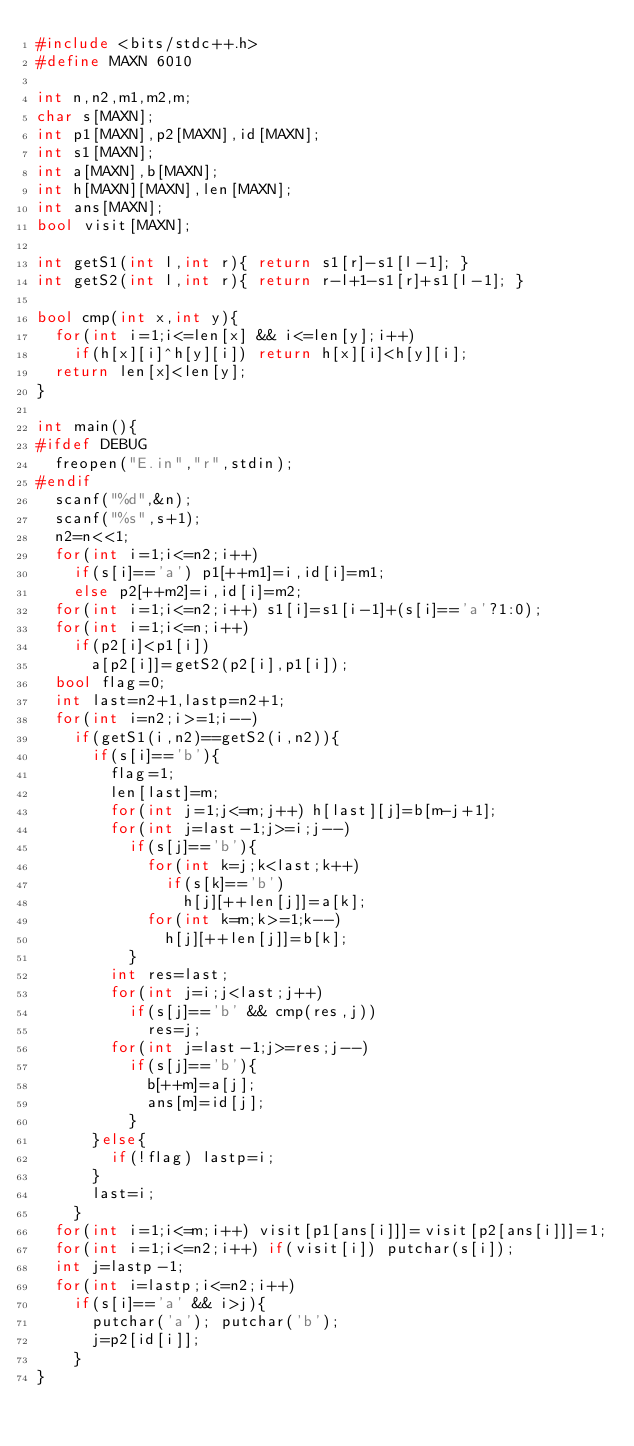<code> <loc_0><loc_0><loc_500><loc_500><_C++_>#include <bits/stdc++.h>
#define MAXN 6010

int n,n2,m1,m2,m;
char s[MAXN];
int p1[MAXN],p2[MAXN],id[MAXN];
int s1[MAXN];
int a[MAXN],b[MAXN];
int h[MAXN][MAXN],len[MAXN];
int ans[MAXN];
bool visit[MAXN];

int getS1(int l,int r){ return s1[r]-s1[l-1]; }
int getS2(int l,int r){ return r-l+1-s1[r]+s1[l-1]; }

bool cmp(int x,int y){
	for(int i=1;i<=len[x] && i<=len[y];i++)
		if(h[x][i]^h[y][i]) return h[x][i]<h[y][i];
	return len[x]<len[y];
}

int main(){
#ifdef DEBUG
	freopen("E.in","r",stdin);
#endif
	scanf("%d",&n);
	scanf("%s",s+1);
	n2=n<<1;
	for(int i=1;i<=n2;i++)
		if(s[i]=='a') p1[++m1]=i,id[i]=m1;
		else p2[++m2]=i,id[i]=m2;
	for(int i=1;i<=n2;i++) s1[i]=s1[i-1]+(s[i]=='a'?1:0);
	for(int i=1;i<=n;i++)
		if(p2[i]<p1[i])
			a[p2[i]]=getS2(p2[i],p1[i]);
	bool flag=0;
	int last=n2+1,lastp=n2+1;
	for(int i=n2;i>=1;i--)
		if(getS1(i,n2)==getS2(i,n2)){
			if(s[i]=='b'){
				flag=1;
				len[last]=m;
				for(int j=1;j<=m;j++) h[last][j]=b[m-j+1];
				for(int j=last-1;j>=i;j--)
					if(s[j]=='b'){
						for(int k=j;k<last;k++)
							if(s[k]=='b')
								h[j][++len[j]]=a[k];
						for(int k=m;k>=1;k--)
							h[j][++len[j]]=b[k];
					}
				int res=last;
				for(int j=i;j<last;j++)
					if(s[j]=='b' && cmp(res,j))
						res=j;
				for(int j=last-1;j>=res;j--)
					if(s[j]=='b'){
						b[++m]=a[j];
						ans[m]=id[j];
					}
			}else{
				if(!flag) lastp=i;
			}
			last=i;
		}
	for(int i=1;i<=m;i++) visit[p1[ans[i]]]=visit[p2[ans[i]]]=1;
	for(int i=1;i<=n2;i++) if(visit[i]) putchar(s[i]);
	int j=lastp-1;
	for(int i=lastp;i<=n2;i++)
		if(s[i]=='a' && i>j){
			putchar('a'); putchar('b');
			j=p2[id[i]];
		}
}
</code> 